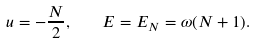<formula> <loc_0><loc_0><loc_500><loc_500>u = - \frac { N } { 2 } , \quad E = E _ { N } = \omega ( N + 1 ) .</formula> 